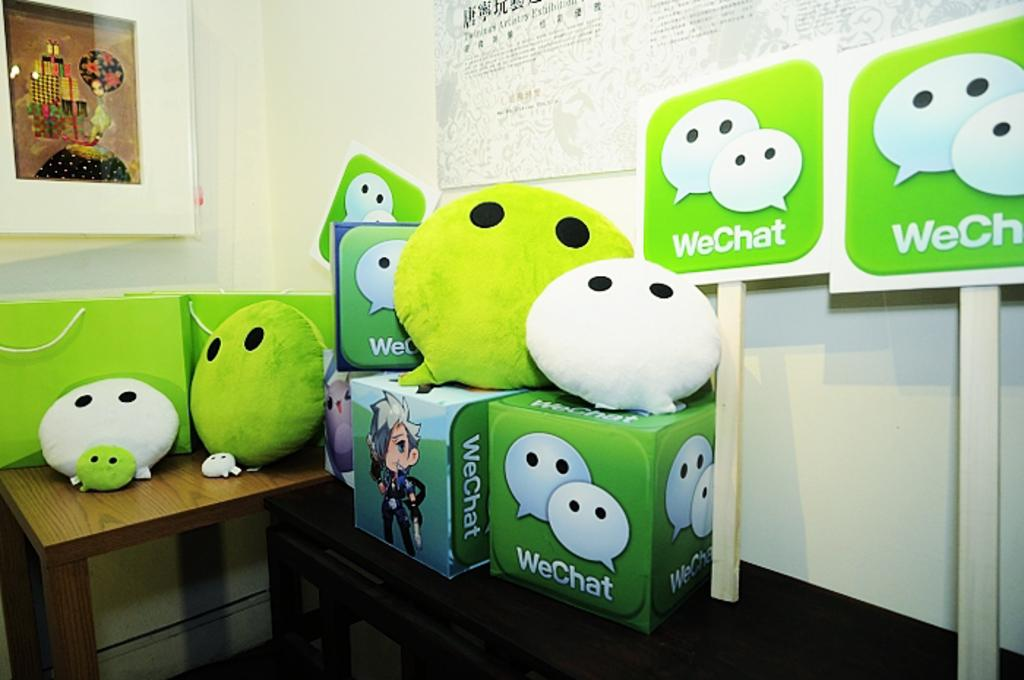What object is placed on the table in the image? There is a bag on the table. What can be seen on the wall in the image? There is a frame on the wall. What type of pollution is visible in the image? There is no pollution visible in the image; it only features a bag on the table and a frame on the wall. What invention is being used to hold the frame on the wall? The image does not show any specific invention being used to hold the frame on the wall; it only shows the frame itself. 